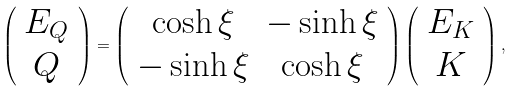Convert formula to latex. <formula><loc_0><loc_0><loc_500><loc_500>\left ( \begin{array} { c } E _ { Q } \\ Q \end{array} \right ) = \left ( \begin{array} { c c } \cosh \xi & - \sinh \xi \\ - \sinh \xi & \cosh \xi \end{array} \right ) \left ( \begin{array} { c } E _ { K } \\ K \end{array} \right ) ,</formula> 